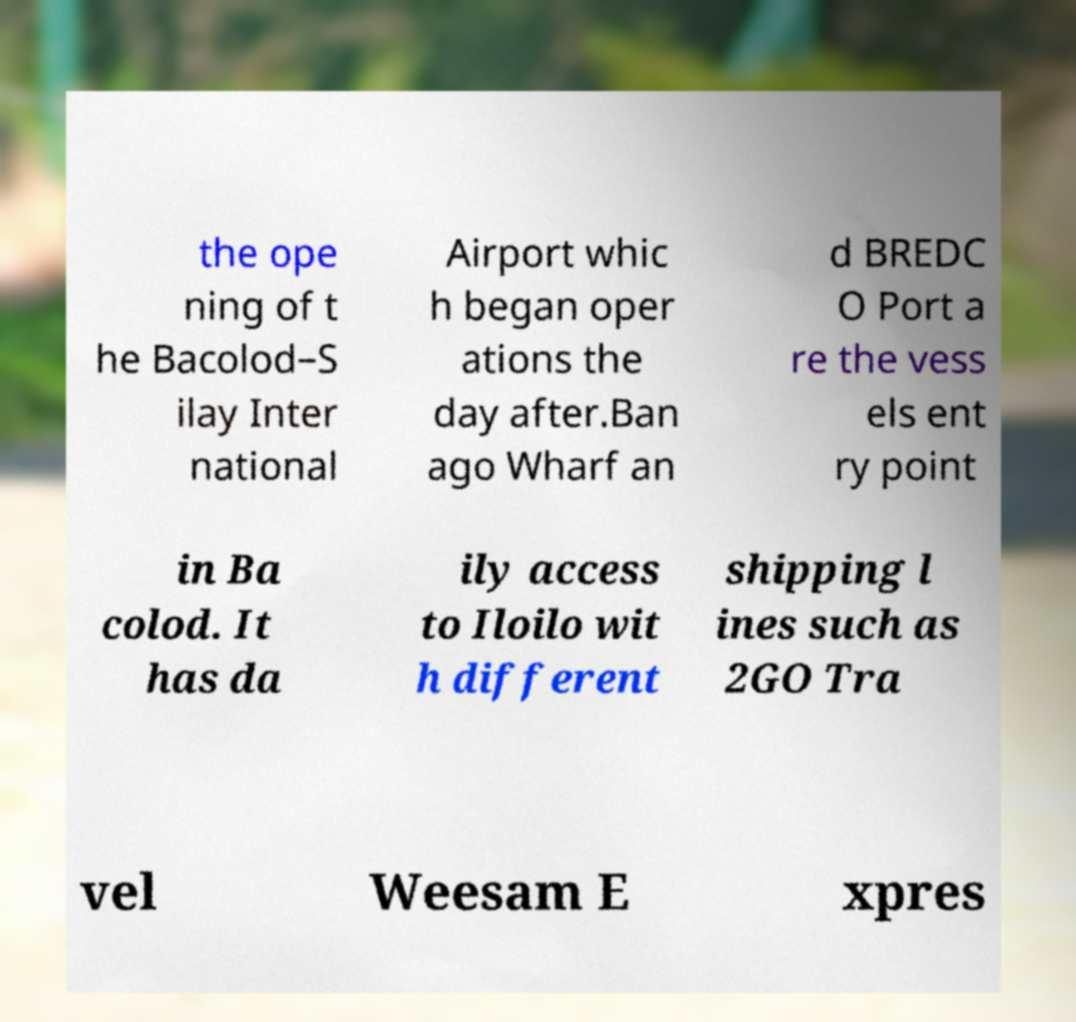Could you assist in decoding the text presented in this image and type it out clearly? the ope ning of t he Bacolod–S ilay Inter national Airport whic h began oper ations the day after.Ban ago Wharf an d BREDC O Port a re the vess els ent ry point in Ba colod. It has da ily access to Iloilo wit h different shipping l ines such as 2GO Tra vel Weesam E xpres 